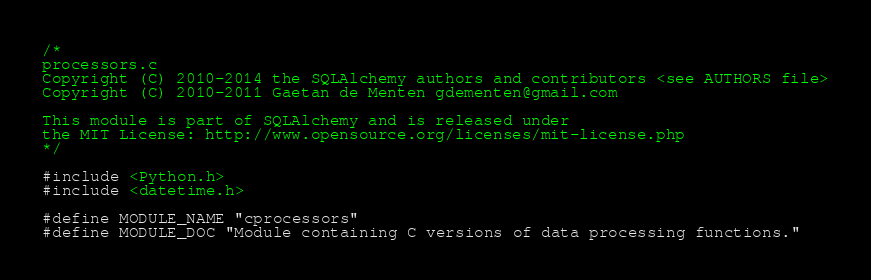Convert code to text. <code><loc_0><loc_0><loc_500><loc_500><_C_>/*
processors.c
Copyright (C) 2010-2014 the SQLAlchemy authors and contributors <see AUTHORS file>
Copyright (C) 2010-2011 Gaetan de Menten gdementen@gmail.com

This module is part of SQLAlchemy and is released under
the MIT License: http://www.opensource.org/licenses/mit-license.php
*/

#include <Python.h>
#include <datetime.h>

#define MODULE_NAME "cprocessors"
#define MODULE_DOC "Module containing C versions of data processing functions."
</code> 